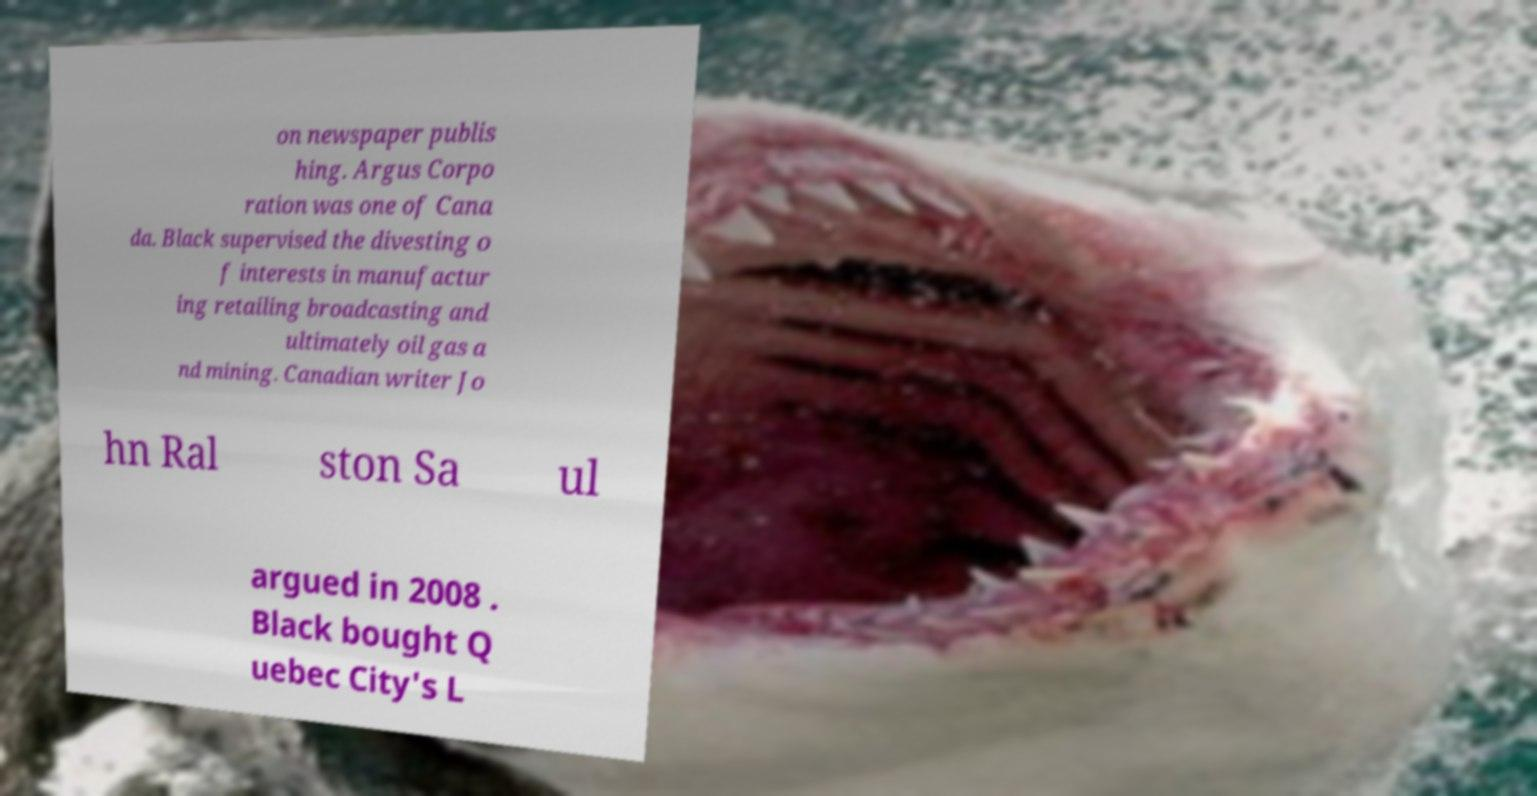I need the written content from this picture converted into text. Can you do that? on newspaper publis hing. Argus Corpo ration was one of Cana da. Black supervised the divesting o f interests in manufactur ing retailing broadcasting and ultimately oil gas a nd mining. Canadian writer Jo hn Ral ston Sa ul argued in 2008 . Black bought Q uebec City's L 